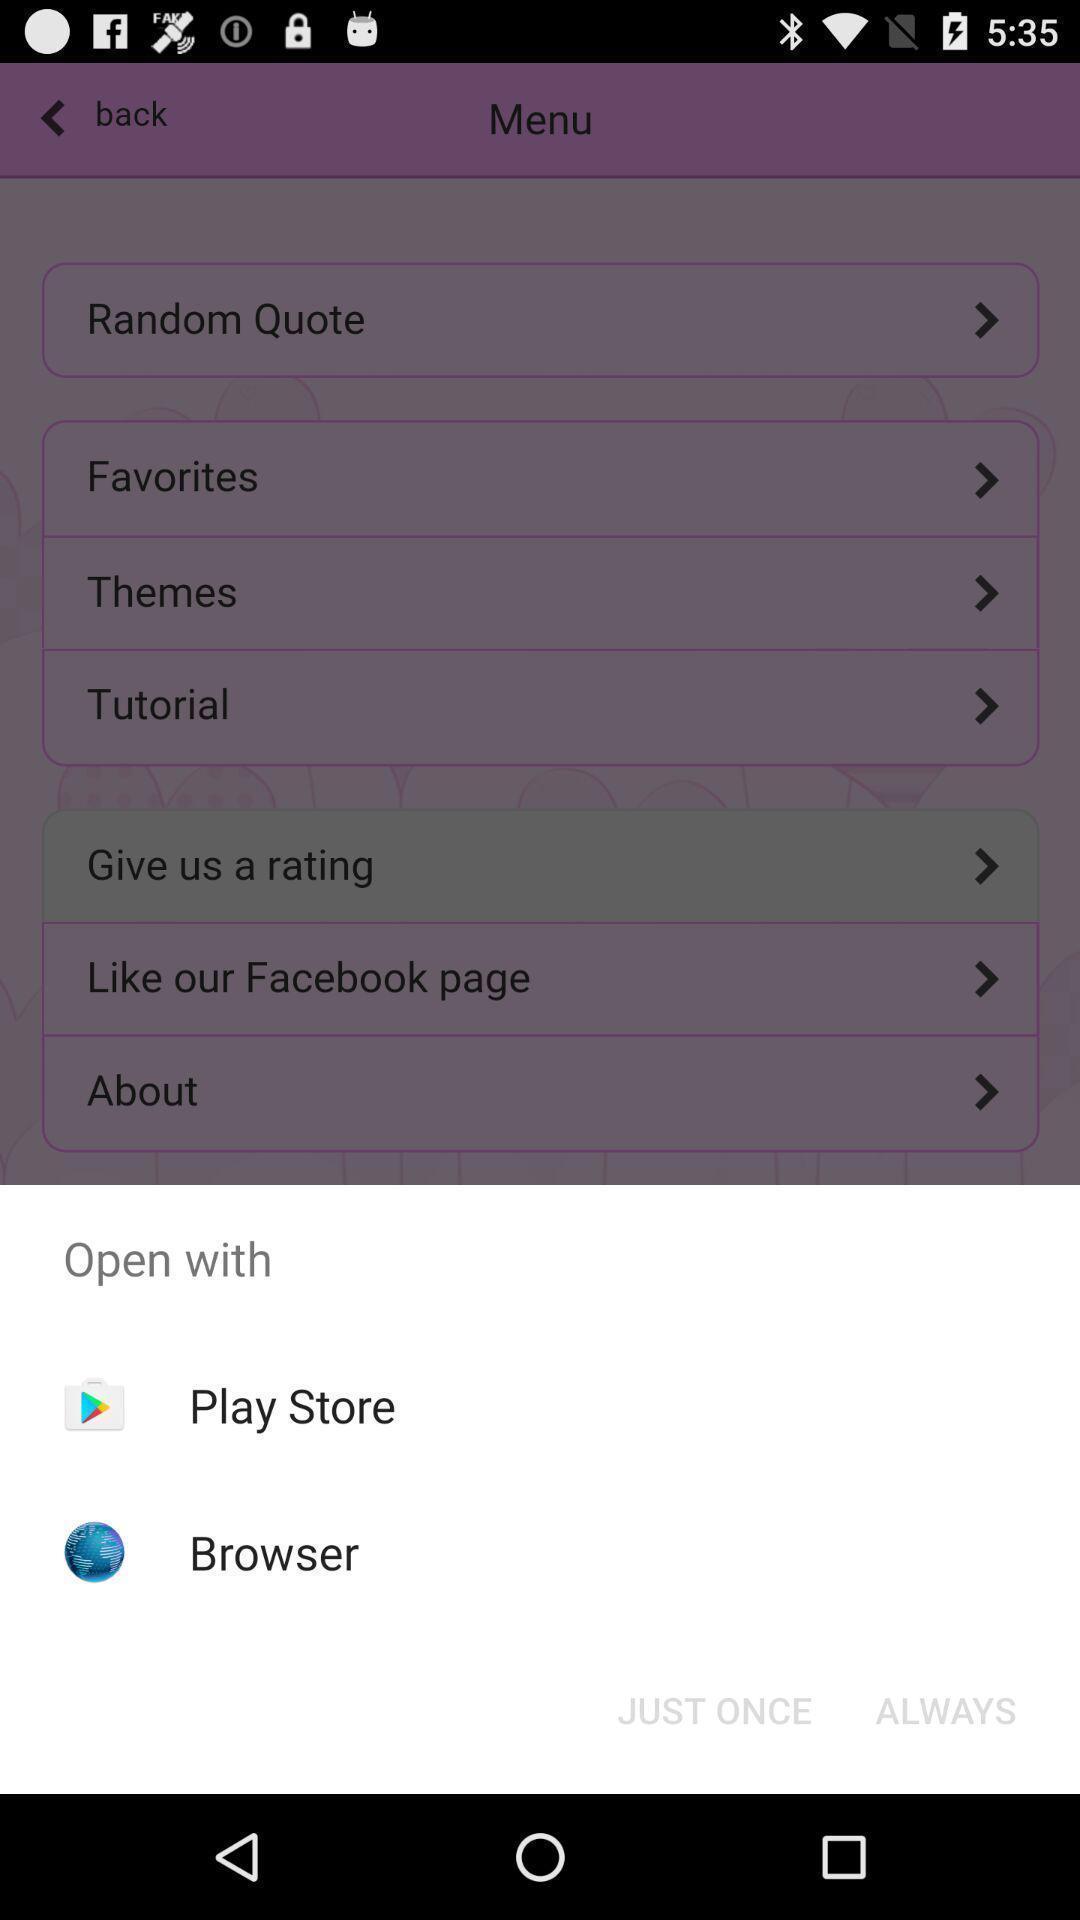Explain what's happening in this screen capture. Popup of applications to browse. 